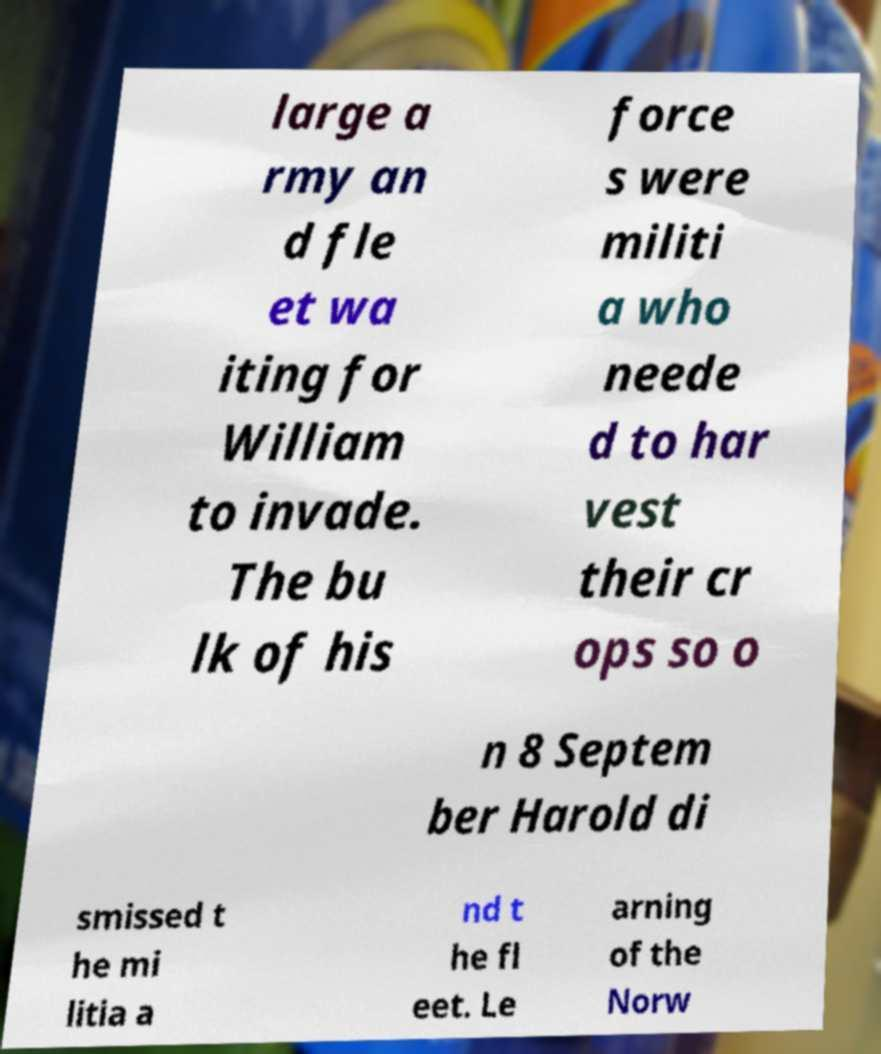Can you read and provide the text displayed in the image?This photo seems to have some interesting text. Can you extract and type it out for me? large a rmy an d fle et wa iting for William to invade. The bu lk of his force s were militi a who neede d to har vest their cr ops so o n 8 Septem ber Harold di smissed t he mi litia a nd t he fl eet. Le arning of the Norw 